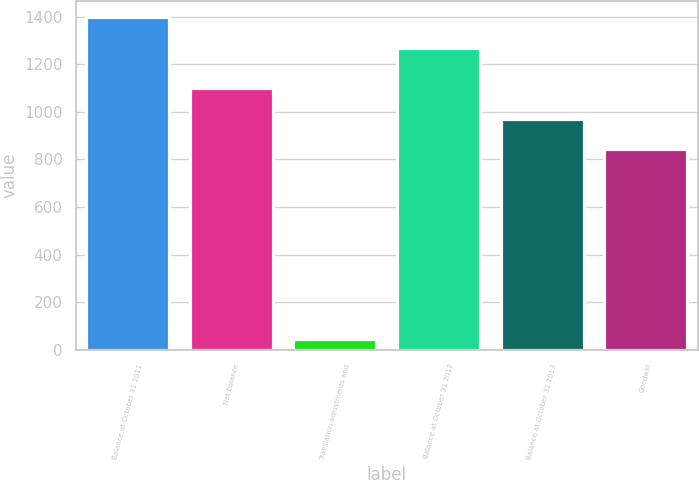Convert chart to OTSL. <chart><loc_0><loc_0><loc_500><loc_500><bar_chart><fcel>Balance at October 31 2011<fcel>Net balance<fcel>Translation adjustments and<fcel>Balance at October 31 2012<fcel>Balance at October 31 2013<fcel>Goodwill<nl><fcel>1397<fcel>1099<fcel>46<fcel>1270<fcel>972<fcel>845<nl></chart> 